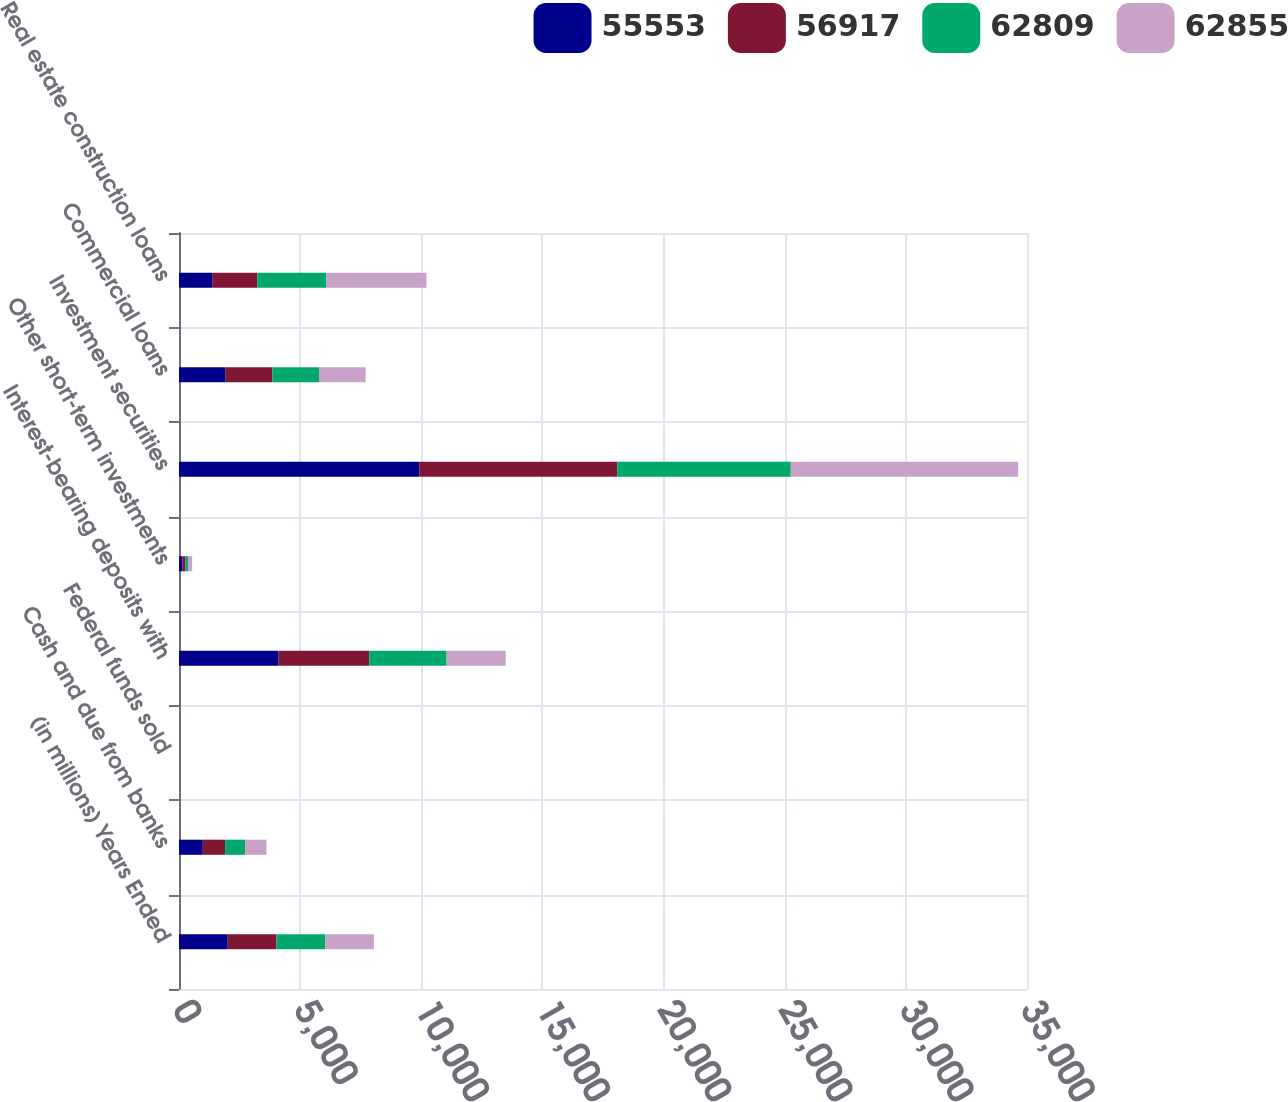Convert chart. <chart><loc_0><loc_0><loc_500><loc_500><stacked_bar_chart><ecel><fcel>(in millions) Years Ended<fcel>Cash and due from banks<fcel>Federal funds sold<fcel>Interest-bearing deposits with<fcel>Other short-term investments<fcel>Investment securities<fcel>Commercial loans<fcel>Real estate construction loans<nl><fcel>55553<fcel>2012<fcel>983<fcel>17<fcel>4112<fcel>134<fcel>9915<fcel>1926<fcel>1390<nl><fcel>56917<fcel>2011<fcel>921<fcel>5<fcel>3741<fcel>129<fcel>8171<fcel>1926<fcel>1843<nl><fcel>62809<fcel>2010<fcel>825<fcel>6<fcel>3191<fcel>126<fcel>7164<fcel>1926<fcel>2839<nl><fcel>62855<fcel>2009<fcel>883<fcel>18<fcel>2440<fcel>154<fcel>9388<fcel>1926<fcel>4140<nl></chart> 